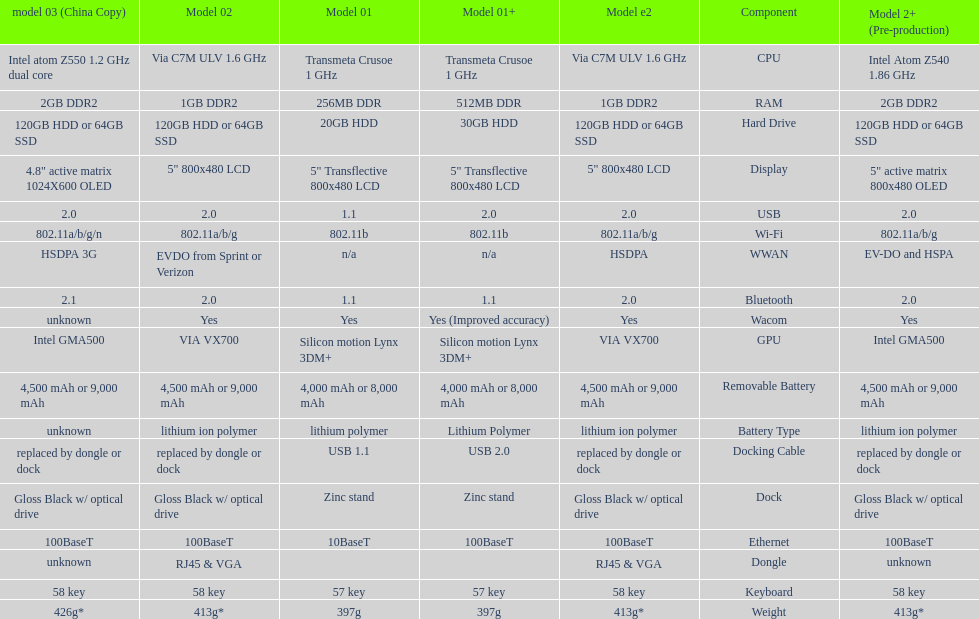Are there at least 13 different components on the chart? Yes. 